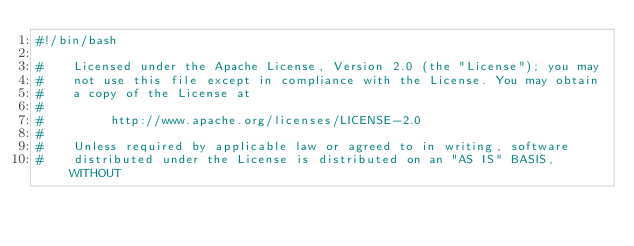<code> <loc_0><loc_0><loc_500><loc_500><_Bash_>#!/bin/bash

#    Licensed under the Apache License, Version 2.0 (the "License"); you may
#    not use this file except in compliance with the License. You may obtain
#    a copy of the License at
#
#         http://www.apache.org/licenses/LICENSE-2.0
#
#    Unless required by applicable law or agreed to in writing, software
#    distributed under the License is distributed on an "AS IS" BASIS, WITHOUT</code> 